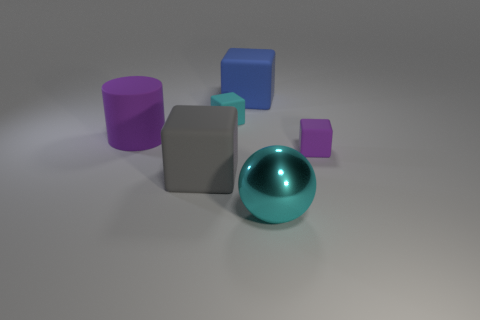There is a tiny cube that is on the left side of the cyan sphere; is it the same color as the large shiny sphere?
Make the answer very short. Yes. Are there any other things that have the same color as the big metal ball?
Offer a terse response. Yes. There is a tiny matte thing that is in front of the cylinder; is its color the same as the thing on the left side of the large gray matte block?
Your response must be concise. Yes. What color is the large thing that is in front of the big purple matte cylinder and to the left of the ball?
Make the answer very short. Gray. What number of other things are the same shape as the small cyan rubber object?
Provide a short and direct response. 3. What is the color of the shiny thing that is the same size as the blue block?
Provide a succinct answer. Cyan. There is a small matte cube that is to the right of the small cyan rubber object; what color is it?
Offer a terse response. Purple. Are there any tiny matte things that are on the left side of the cyan object that is to the right of the big blue rubber thing?
Make the answer very short. Yes. Do the blue matte object and the small rubber thing that is in front of the big purple cylinder have the same shape?
Offer a very short reply. Yes. There is a rubber block that is both behind the gray object and on the left side of the big blue rubber cube; what size is it?
Your answer should be compact. Small. 